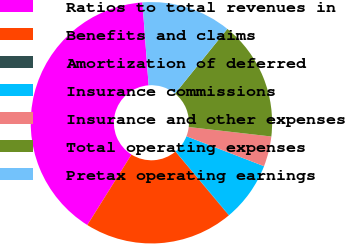<chart> <loc_0><loc_0><loc_500><loc_500><pie_chart><fcel>Ratios to total revenues in<fcel>Benefits and claims<fcel>Amortization of deferred<fcel>Insurance commissions<fcel>Insurance and other expenses<fcel>Total operating expenses<fcel>Pretax operating earnings<nl><fcel>39.9%<fcel>19.98%<fcel>0.05%<fcel>8.02%<fcel>4.04%<fcel>15.99%<fcel>12.01%<nl></chart> 